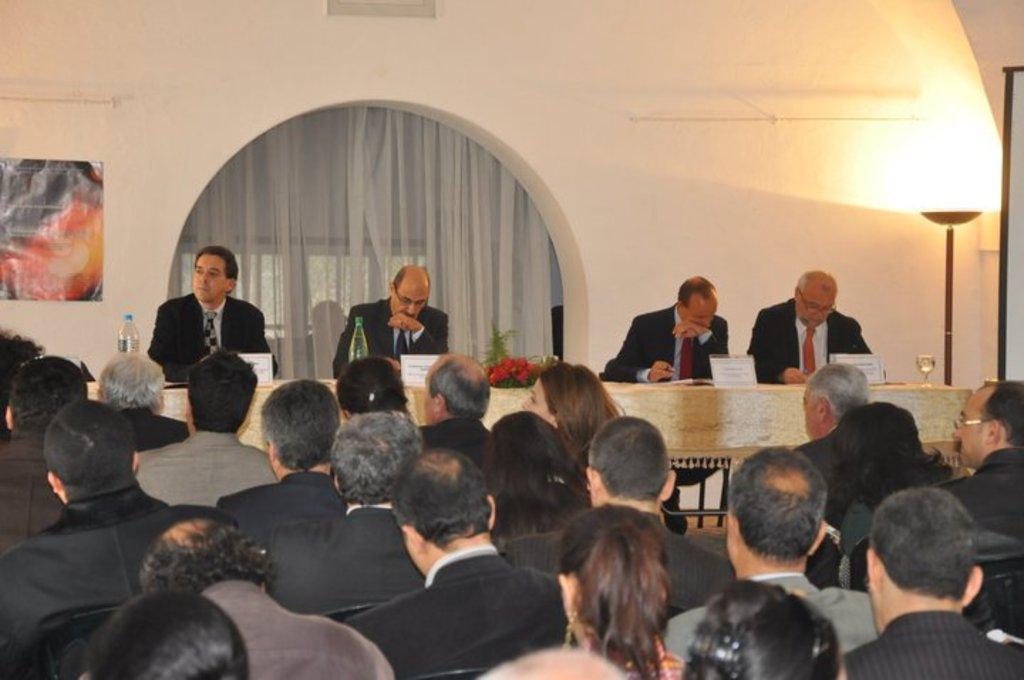How would you summarize this image in a sentence or two? In the picture I can see four persons sitting and there is a table in front of them which has few objects placed on it and there are few persons sitting in front of them and there are few other objects in the background. 